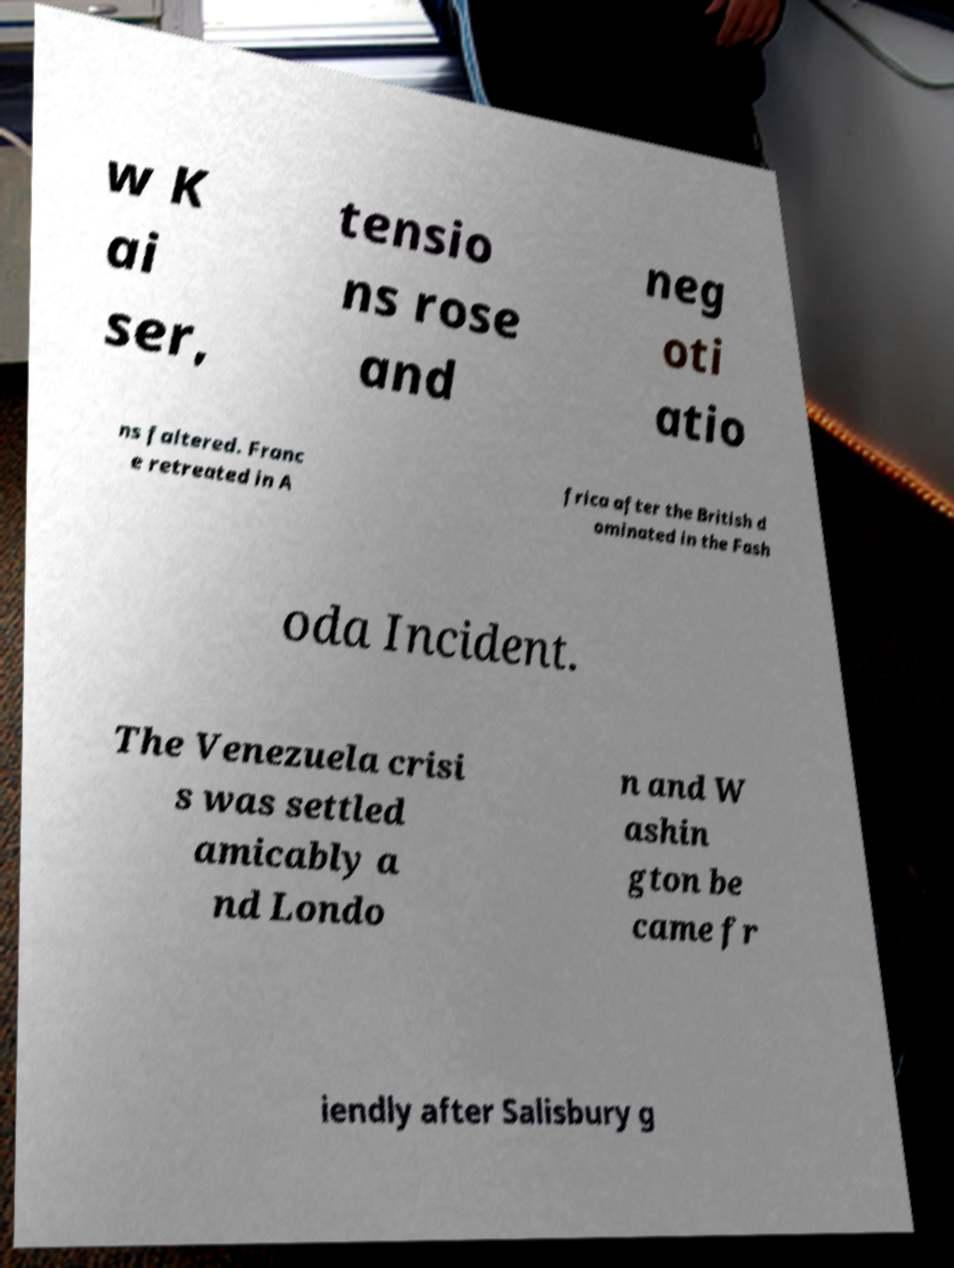There's text embedded in this image that I need extracted. Can you transcribe it verbatim? w K ai ser, tensio ns rose and neg oti atio ns faltered. Franc e retreated in A frica after the British d ominated in the Fash oda Incident. The Venezuela crisi s was settled amicably a nd Londo n and W ashin gton be came fr iendly after Salisbury g 